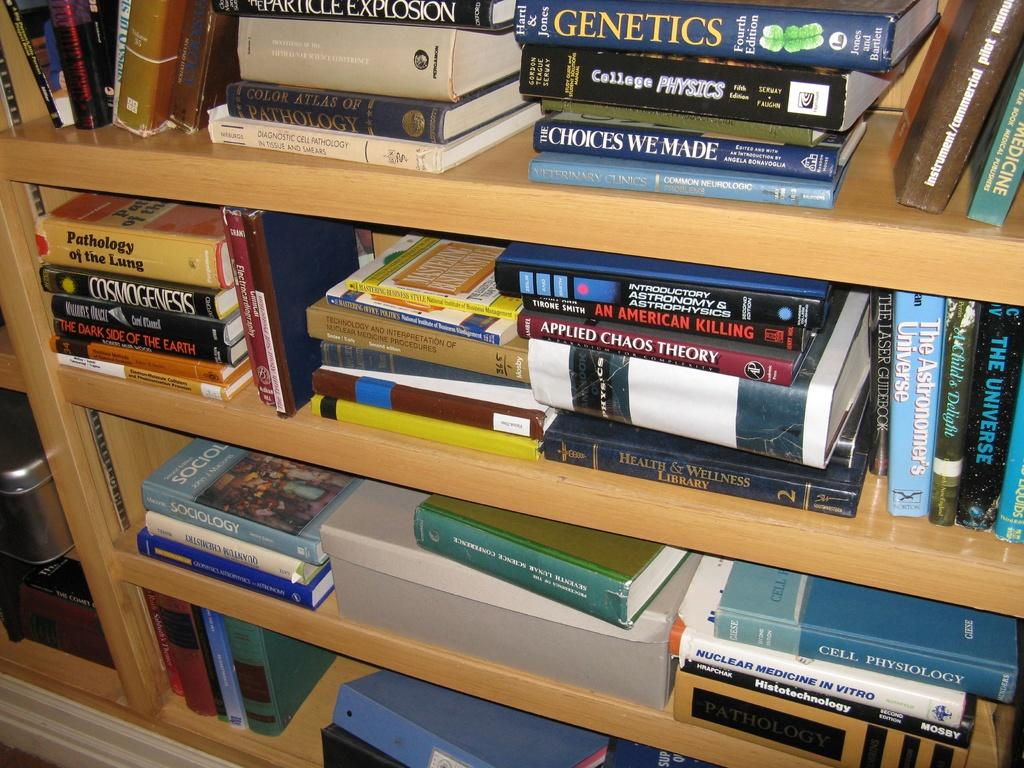<image>
Share a concise interpretation of the image provided. Many books, including Applied Chaos Theory and An American Killing, fill a shelf. 